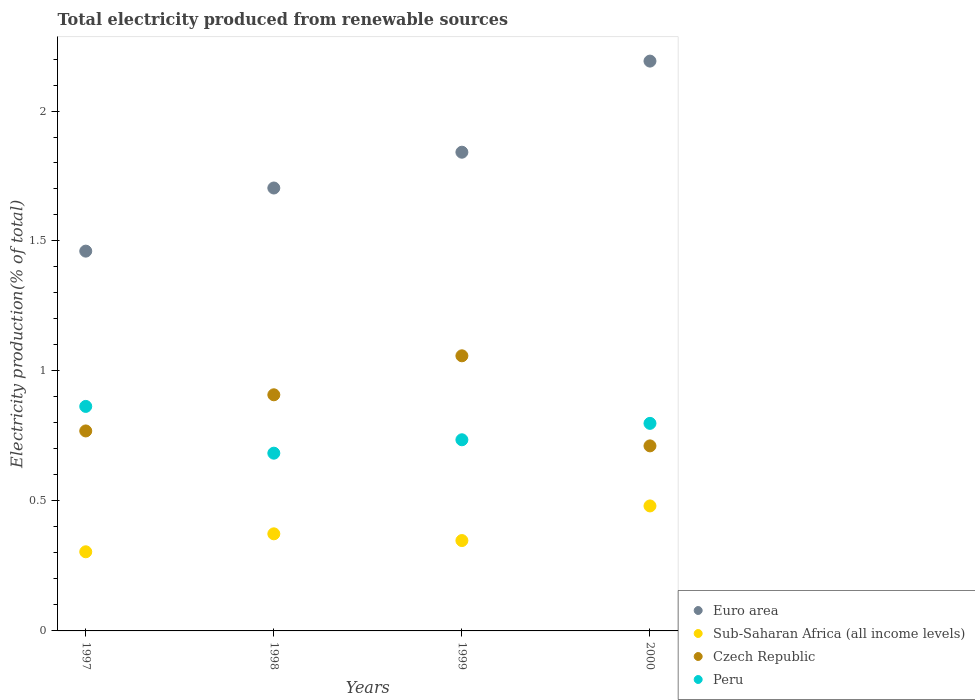How many different coloured dotlines are there?
Offer a very short reply. 4. Is the number of dotlines equal to the number of legend labels?
Provide a short and direct response. Yes. What is the total electricity produced in Euro area in 1999?
Your answer should be compact. 1.84. Across all years, what is the maximum total electricity produced in Czech Republic?
Make the answer very short. 1.06. Across all years, what is the minimum total electricity produced in Sub-Saharan Africa (all income levels)?
Keep it short and to the point. 0.3. What is the total total electricity produced in Sub-Saharan Africa (all income levels) in the graph?
Your response must be concise. 1.51. What is the difference between the total electricity produced in Euro area in 1997 and that in 1998?
Give a very brief answer. -0.24. What is the difference between the total electricity produced in Euro area in 1998 and the total electricity produced in Czech Republic in 1999?
Ensure brevity in your answer.  0.65. What is the average total electricity produced in Peru per year?
Ensure brevity in your answer.  0.77. In the year 1998, what is the difference between the total electricity produced in Peru and total electricity produced in Czech Republic?
Offer a very short reply. -0.22. In how many years, is the total electricity produced in Peru greater than 0.1 %?
Your answer should be very brief. 4. What is the ratio of the total electricity produced in Czech Republic in 1998 to that in 2000?
Give a very brief answer. 1.28. Is the total electricity produced in Peru in 1998 less than that in 2000?
Your answer should be compact. Yes. What is the difference between the highest and the second highest total electricity produced in Sub-Saharan Africa (all income levels)?
Keep it short and to the point. 0.11. What is the difference between the highest and the lowest total electricity produced in Peru?
Your answer should be very brief. 0.18. In how many years, is the total electricity produced in Czech Republic greater than the average total electricity produced in Czech Republic taken over all years?
Ensure brevity in your answer.  2. Is it the case that in every year, the sum of the total electricity produced in Czech Republic and total electricity produced in Sub-Saharan Africa (all income levels)  is greater than the sum of total electricity produced in Peru and total electricity produced in Euro area?
Your response must be concise. No. Does the total electricity produced in Euro area monotonically increase over the years?
Give a very brief answer. Yes. Is the total electricity produced in Sub-Saharan Africa (all income levels) strictly less than the total electricity produced in Czech Republic over the years?
Your answer should be compact. Yes. How many years are there in the graph?
Provide a short and direct response. 4. Does the graph contain any zero values?
Your response must be concise. No. Where does the legend appear in the graph?
Keep it short and to the point. Bottom right. What is the title of the graph?
Your answer should be compact. Total electricity produced from renewable sources. What is the label or title of the Y-axis?
Your response must be concise. Electricity production(% of total). What is the Electricity production(% of total) of Euro area in 1997?
Offer a terse response. 1.46. What is the Electricity production(% of total) of Sub-Saharan Africa (all income levels) in 1997?
Provide a short and direct response. 0.3. What is the Electricity production(% of total) of Czech Republic in 1997?
Make the answer very short. 0.77. What is the Electricity production(% of total) of Peru in 1997?
Keep it short and to the point. 0.86. What is the Electricity production(% of total) in Euro area in 1998?
Your answer should be very brief. 1.7. What is the Electricity production(% of total) in Sub-Saharan Africa (all income levels) in 1998?
Your answer should be compact. 0.37. What is the Electricity production(% of total) of Czech Republic in 1998?
Give a very brief answer. 0.91. What is the Electricity production(% of total) in Peru in 1998?
Keep it short and to the point. 0.68. What is the Electricity production(% of total) of Euro area in 1999?
Give a very brief answer. 1.84. What is the Electricity production(% of total) of Sub-Saharan Africa (all income levels) in 1999?
Keep it short and to the point. 0.35. What is the Electricity production(% of total) of Czech Republic in 1999?
Make the answer very short. 1.06. What is the Electricity production(% of total) of Peru in 1999?
Make the answer very short. 0.74. What is the Electricity production(% of total) of Euro area in 2000?
Offer a very short reply. 2.19. What is the Electricity production(% of total) of Sub-Saharan Africa (all income levels) in 2000?
Your response must be concise. 0.48. What is the Electricity production(% of total) in Czech Republic in 2000?
Ensure brevity in your answer.  0.71. What is the Electricity production(% of total) in Peru in 2000?
Your response must be concise. 0.8. Across all years, what is the maximum Electricity production(% of total) in Euro area?
Give a very brief answer. 2.19. Across all years, what is the maximum Electricity production(% of total) of Sub-Saharan Africa (all income levels)?
Keep it short and to the point. 0.48. Across all years, what is the maximum Electricity production(% of total) of Czech Republic?
Give a very brief answer. 1.06. Across all years, what is the maximum Electricity production(% of total) of Peru?
Give a very brief answer. 0.86. Across all years, what is the minimum Electricity production(% of total) in Euro area?
Ensure brevity in your answer.  1.46. Across all years, what is the minimum Electricity production(% of total) in Sub-Saharan Africa (all income levels)?
Provide a succinct answer. 0.3. Across all years, what is the minimum Electricity production(% of total) in Czech Republic?
Your response must be concise. 0.71. Across all years, what is the minimum Electricity production(% of total) of Peru?
Your answer should be very brief. 0.68. What is the total Electricity production(% of total) in Euro area in the graph?
Your answer should be very brief. 7.2. What is the total Electricity production(% of total) of Sub-Saharan Africa (all income levels) in the graph?
Your response must be concise. 1.51. What is the total Electricity production(% of total) in Czech Republic in the graph?
Your answer should be very brief. 3.45. What is the total Electricity production(% of total) in Peru in the graph?
Your answer should be very brief. 3.08. What is the difference between the Electricity production(% of total) in Euro area in 1997 and that in 1998?
Provide a succinct answer. -0.24. What is the difference between the Electricity production(% of total) in Sub-Saharan Africa (all income levels) in 1997 and that in 1998?
Provide a succinct answer. -0.07. What is the difference between the Electricity production(% of total) in Czech Republic in 1997 and that in 1998?
Your answer should be compact. -0.14. What is the difference between the Electricity production(% of total) in Peru in 1997 and that in 1998?
Offer a terse response. 0.18. What is the difference between the Electricity production(% of total) of Euro area in 1997 and that in 1999?
Your answer should be very brief. -0.38. What is the difference between the Electricity production(% of total) in Sub-Saharan Africa (all income levels) in 1997 and that in 1999?
Your answer should be compact. -0.04. What is the difference between the Electricity production(% of total) of Czech Republic in 1997 and that in 1999?
Make the answer very short. -0.29. What is the difference between the Electricity production(% of total) in Peru in 1997 and that in 1999?
Keep it short and to the point. 0.13. What is the difference between the Electricity production(% of total) of Euro area in 1997 and that in 2000?
Offer a terse response. -0.73. What is the difference between the Electricity production(% of total) of Sub-Saharan Africa (all income levels) in 1997 and that in 2000?
Offer a terse response. -0.18. What is the difference between the Electricity production(% of total) of Czech Republic in 1997 and that in 2000?
Offer a very short reply. 0.06. What is the difference between the Electricity production(% of total) in Peru in 1997 and that in 2000?
Offer a terse response. 0.07. What is the difference between the Electricity production(% of total) of Euro area in 1998 and that in 1999?
Keep it short and to the point. -0.14. What is the difference between the Electricity production(% of total) of Sub-Saharan Africa (all income levels) in 1998 and that in 1999?
Keep it short and to the point. 0.03. What is the difference between the Electricity production(% of total) of Czech Republic in 1998 and that in 1999?
Your answer should be compact. -0.15. What is the difference between the Electricity production(% of total) in Peru in 1998 and that in 1999?
Ensure brevity in your answer.  -0.05. What is the difference between the Electricity production(% of total) of Euro area in 1998 and that in 2000?
Your answer should be compact. -0.49. What is the difference between the Electricity production(% of total) of Sub-Saharan Africa (all income levels) in 1998 and that in 2000?
Your answer should be compact. -0.11. What is the difference between the Electricity production(% of total) in Czech Republic in 1998 and that in 2000?
Offer a very short reply. 0.2. What is the difference between the Electricity production(% of total) in Peru in 1998 and that in 2000?
Make the answer very short. -0.11. What is the difference between the Electricity production(% of total) in Euro area in 1999 and that in 2000?
Provide a succinct answer. -0.35. What is the difference between the Electricity production(% of total) of Sub-Saharan Africa (all income levels) in 1999 and that in 2000?
Offer a very short reply. -0.13. What is the difference between the Electricity production(% of total) in Czech Republic in 1999 and that in 2000?
Offer a terse response. 0.35. What is the difference between the Electricity production(% of total) in Peru in 1999 and that in 2000?
Offer a terse response. -0.06. What is the difference between the Electricity production(% of total) of Euro area in 1997 and the Electricity production(% of total) of Sub-Saharan Africa (all income levels) in 1998?
Provide a short and direct response. 1.09. What is the difference between the Electricity production(% of total) in Euro area in 1997 and the Electricity production(% of total) in Czech Republic in 1998?
Keep it short and to the point. 0.55. What is the difference between the Electricity production(% of total) in Euro area in 1997 and the Electricity production(% of total) in Peru in 1998?
Offer a very short reply. 0.78. What is the difference between the Electricity production(% of total) in Sub-Saharan Africa (all income levels) in 1997 and the Electricity production(% of total) in Czech Republic in 1998?
Make the answer very short. -0.6. What is the difference between the Electricity production(% of total) in Sub-Saharan Africa (all income levels) in 1997 and the Electricity production(% of total) in Peru in 1998?
Provide a short and direct response. -0.38. What is the difference between the Electricity production(% of total) of Czech Republic in 1997 and the Electricity production(% of total) of Peru in 1998?
Your answer should be very brief. 0.09. What is the difference between the Electricity production(% of total) in Euro area in 1997 and the Electricity production(% of total) in Sub-Saharan Africa (all income levels) in 1999?
Offer a very short reply. 1.11. What is the difference between the Electricity production(% of total) in Euro area in 1997 and the Electricity production(% of total) in Czech Republic in 1999?
Provide a succinct answer. 0.4. What is the difference between the Electricity production(% of total) in Euro area in 1997 and the Electricity production(% of total) in Peru in 1999?
Give a very brief answer. 0.73. What is the difference between the Electricity production(% of total) of Sub-Saharan Africa (all income levels) in 1997 and the Electricity production(% of total) of Czech Republic in 1999?
Your answer should be very brief. -0.75. What is the difference between the Electricity production(% of total) in Sub-Saharan Africa (all income levels) in 1997 and the Electricity production(% of total) in Peru in 1999?
Give a very brief answer. -0.43. What is the difference between the Electricity production(% of total) in Czech Republic in 1997 and the Electricity production(% of total) in Peru in 1999?
Offer a very short reply. 0.03. What is the difference between the Electricity production(% of total) of Euro area in 1997 and the Electricity production(% of total) of Sub-Saharan Africa (all income levels) in 2000?
Your answer should be very brief. 0.98. What is the difference between the Electricity production(% of total) in Euro area in 1997 and the Electricity production(% of total) in Czech Republic in 2000?
Give a very brief answer. 0.75. What is the difference between the Electricity production(% of total) of Euro area in 1997 and the Electricity production(% of total) of Peru in 2000?
Provide a short and direct response. 0.66. What is the difference between the Electricity production(% of total) of Sub-Saharan Africa (all income levels) in 1997 and the Electricity production(% of total) of Czech Republic in 2000?
Ensure brevity in your answer.  -0.41. What is the difference between the Electricity production(% of total) of Sub-Saharan Africa (all income levels) in 1997 and the Electricity production(% of total) of Peru in 2000?
Ensure brevity in your answer.  -0.49. What is the difference between the Electricity production(% of total) in Czech Republic in 1997 and the Electricity production(% of total) in Peru in 2000?
Your answer should be compact. -0.03. What is the difference between the Electricity production(% of total) in Euro area in 1998 and the Electricity production(% of total) in Sub-Saharan Africa (all income levels) in 1999?
Give a very brief answer. 1.36. What is the difference between the Electricity production(% of total) in Euro area in 1998 and the Electricity production(% of total) in Czech Republic in 1999?
Your response must be concise. 0.65. What is the difference between the Electricity production(% of total) in Euro area in 1998 and the Electricity production(% of total) in Peru in 1999?
Your answer should be very brief. 0.97. What is the difference between the Electricity production(% of total) of Sub-Saharan Africa (all income levels) in 1998 and the Electricity production(% of total) of Czech Republic in 1999?
Your answer should be compact. -0.68. What is the difference between the Electricity production(% of total) in Sub-Saharan Africa (all income levels) in 1998 and the Electricity production(% of total) in Peru in 1999?
Your response must be concise. -0.36. What is the difference between the Electricity production(% of total) in Czech Republic in 1998 and the Electricity production(% of total) in Peru in 1999?
Provide a succinct answer. 0.17. What is the difference between the Electricity production(% of total) of Euro area in 1998 and the Electricity production(% of total) of Sub-Saharan Africa (all income levels) in 2000?
Provide a succinct answer. 1.22. What is the difference between the Electricity production(% of total) of Euro area in 1998 and the Electricity production(% of total) of Peru in 2000?
Give a very brief answer. 0.91. What is the difference between the Electricity production(% of total) in Sub-Saharan Africa (all income levels) in 1998 and the Electricity production(% of total) in Czech Republic in 2000?
Make the answer very short. -0.34. What is the difference between the Electricity production(% of total) in Sub-Saharan Africa (all income levels) in 1998 and the Electricity production(% of total) in Peru in 2000?
Provide a short and direct response. -0.42. What is the difference between the Electricity production(% of total) of Czech Republic in 1998 and the Electricity production(% of total) of Peru in 2000?
Make the answer very short. 0.11. What is the difference between the Electricity production(% of total) in Euro area in 1999 and the Electricity production(% of total) in Sub-Saharan Africa (all income levels) in 2000?
Make the answer very short. 1.36. What is the difference between the Electricity production(% of total) in Euro area in 1999 and the Electricity production(% of total) in Czech Republic in 2000?
Make the answer very short. 1.13. What is the difference between the Electricity production(% of total) of Euro area in 1999 and the Electricity production(% of total) of Peru in 2000?
Ensure brevity in your answer.  1.04. What is the difference between the Electricity production(% of total) in Sub-Saharan Africa (all income levels) in 1999 and the Electricity production(% of total) in Czech Republic in 2000?
Your answer should be compact. -0.36. What is the difference between the Electricity production(% of total) of Sub-Saharan Africa (all income levels) in 1999 and the Electricity production(% of total) of Peru in 2000?
Provide a succinct answer. -0.45. What is the difference between the Electricity production(% of total) in Czech Republic in 1999 and the Electricity production(% of total) in Peru in 2000?
Provide a succinct answer. 0.26. What is the average Electricity production(% of total) of Euro area per year?
Your answer should be compact. 1.8. What is the average Electricity production(% of total) in Sub-Saharan Africa (all income levels) per year?
Ensure brevity in your answer.  0.38. What is the average Electricity production(% of total) in Czech Republic per year?
Provide a short and direct response. 0.86. What is the average Electricity production(% of total) of Peru per year?
Keep it short and to the point. 0.77. In the year 1997, what is the difference between the Electricity production(% of total) of Euro area and Electricity production(% of total) of Sub-Saharan Africa (all income levels)?
Your answer should be compact. 1.16. In the year 1997, what is the difference between the Electricity production(% of total) of Euro area and Electricity production(% of total) of Czech Republic?
Offer a very short reply. 0.69. In the year 1997, what is the difference between the Electricity production(% of total) of Euro area and Electricity production(% of total) of Peru?
Your response must be concise. 0.6. In the year 1997, what is the difference between the Electricity production(% of total) of Sub-Saharan Africa (all income levels) and Electricity production(% of total) of Czech Republic?
Provide a short and direct response. -0.46. In the year 1997, what is the difference between the Electricity production(% of total) in Sub-Saharan Africa (all income levels) and Electricity production(% of total) in Peru?
Provide a succinct answer. -0.56. In the year 1997, what is the difference between the Electricity production(% of total) of Czech Republic and Electricity production(% of total) of Peru?
Your answer should be very brief. -0.09. In the year 1998, what is the difference between the Electricity production(% of total) of Euro area and Electricity production(% of total) of Sub-Saharan Africa (all income levels)?
Your answer should be compact. 1.33. In the year 1998, what is the difference between the Electricity production(% of total) of Euro area and Electricity production(% of total) of Czech Republic?
Provide a succinct answer. 0.8. In the year 1998, what is the difference between the Electricity production(% of total) of Euro area and Electricity production(% of total) of Peru?
Your answer should be compact. 1.02. In the year 1998, what is the difference between the Electricity production(% of total) in Sub-Saharan Africa (all income levels) and Electricity production(% of total) in Czech Republic?
Ensure brevity in your answer.  -0.53. In the year 1998, what is the difference between the Electricity production(% of total) of Sub-Saharan Africa (all income levels) and Electricity production(% of total) of Peru?
Give a very brief answer. -0.31. In the year 1998, what is the difference between the Electricity production(% of total) of Czech Republic and Electricity production(% of total) of Peru?
Ensure brevity in your answer.  0.22. In the year 1999, what is the difference between the Electricity production(% of total) in Euro area and Electricity production(% of total) in Sub-Saharan Africa (all income levels)?
Give a very brief answer. 1.49. In the year 1999, what is the difference between the Electricity production(% of total) of Euro area and Electricity production(% of total) of Czech Republic?
Keep it short and to the point. 0.78. In the year 1999, what is the difference between the Electricity production(% of total) in Euro area and Electricity production(% of total) in Peru?
Keep it short and to the point. 1.11. In the year 1999, what is the difference between the Electricity production(% of total) of Sub-Saharan Africa (all income levels) and Electricity production(% of total) of Czech Republic?
Provide a short and direct response. -0.71. In the year 1999, what is the difference between the Electricity production(% of total) of Sub-Saharan Africa (all income levels) and Electricity production(% of total) of Peru?
Provide a short and direct response. -0.39. In the year 1999, what is the difference between the Electricity production(% of total) in Czech Republic and Electricity production(% of total) in Peru?
Provide a short and direct response. 0.32. In the year 2000, what is the difference between the Electricity production(% of total) in Euro area and Electricity production(% of total) in Sub-Saharan Africa (all income levels)?
Offer a very short reply. 1.71. In the year 2000, what is the difference between the Electricity production(% of total) in Euro area and Electricity production(% of total) in Czech Republic?
Your response must be concise. 1.48. In the year 2000, what is the difference between the Electricity production(% of total) of Euro area and Electricity production(% of total) of Peru?
Your answer should be compact. 1.39. In the year 2000, what is the difference between the Electricity production(% of total) in Sub-Saharan Africa (all income levels) and Electricity production(% of total) in Czech Republic?
Provide a succinct answer. -0.23. In the year 2000, what is the difference between the Electricity production(% of total) of Sub-Saharan Africa (all income levels) and Electricity production(% of total) of Peru?
Offer a terse response. -0.32. In the year 2000, what is the difference between the Electricity production(% of total) in Czech Republic and Electricity production(% of total) in Peru?
Ensure brevity in your answer.  -0.09. What is the ratio of the Electricity production(% of total) of Euro area in 1997 to that in 1998?
Give a very brief answer. 0.86. What is the ratio of the Electricity production(% of total) in Sub-Saharan Africa (all income levels) in 1997 to that in 1998?
Make the answer very short. 0.81. What is the ratio of the Electricity production(% of total) in Czech Republic in 1997 to that in 1998?
Keep it short and to the point. 0.85. What is the ratio of the Electricity production(% of total) in Peru in 1997 to that in 1998?
Offer a terse response. 1.26. What is the ratio of the Electricity production(% of total) in Euro area in 1997 to that in 1999?
Your response must be concise. 0.79. What is the ratio of the Electricity production(% of total) in Sub-Saharan Africa (all income levels) in 1997 to that in 1999?
Your answer should be compact. 0.88. What is the ratio of the Electricity production(% of total) of Czech Republic in 1997 to that in 1999?
Your answer should be very brief. 0.73. What is the ratio of the Electricity production(% of total) of Peru in 1997 to that in 1999?
Give a very brief answer. 1.17. What is the ratio of the Electricity production(% of total) in Euro area in 1997 to that in 2000?
Offer a very short reply. 0.67. What is the ratio of the Electricity production(% of total) in Sub-Saharan Africa (all income levels) in 1997 to that in 2000?
Give a very brief answer. 0.63. What is the ratio of the Electricity production(% of total) in Czech Republic in 1997 to that in 2000?
Your answer should be very brief. 1.08. What is the ratio of the Electricity production(% of total) in Peru in 1997 to that in 2000?
Your answer should be very brief. 1.08. What is the ratio of the Electricity production(% of total) of Euro area in 1998 to that in 1999?
Your answer should be very brief. 0.93. What is the ratio of the Electricity production(% of total) of Sub-Saharan Africa (all income levels) in 1998 to that in 1999?
Offer a terse response. 1.07. What is the ratio of the Electricity production(% of total) in Czech Republic in 1998 to that in 1999?
Offer a terse response. 0.86. What is the ratio of the Electricity production(% of total) in Peru in 1998 to that in 1999?
Your response must be concise. 0.93. What is the ratio of the Electricity production(% of total) of Euro area in 1998 to that in 2000?
Give a very brief answer. 0.78. What is the ratio of the Electricity production(% of total) of Sub-Saharan Africa (all income levels) in 1998 to that in 2000?
Make the answer very short. 0.78. What is the ratio of the Electricity production(% of total) of Czech Republic in 1998 to that in 2000?
Provide a succinct answer. 1.28. What is the ratio of the Electricity production(% of total) in Peru in 1998 to that in 2000?
Your answer should be very brief. 0.86. What is the ratio of the Electricity production(% of total) of Euro area in 1999 to that in 2000?
Your answer should be compact. 0.84. What is the ratio of the Electricity production(% of total) of Sub-Saharan Africa (all income levels) in 1999 to that in 2000?
Offer a very short reply. 0.72. What is the ratio of the Electricity production(% of total) of Czech Republic in 1999 to that in 2000?
Provide a short and direct response. 1.49. What is the ratio of the Electricity production(% of total) in Peru in 1999 to that in 2000?
Your answer should be compact. 0.92. What is the difference between the highest and the second highest Electricity production(% of total) of Euro area?
Keep it short and to the point. 0.35. What is the difference between the highest and the second highest Electricity production(% of total) in Sub-Saharan Africa (all income levels)?
Offer a very short reply. 0.11. What is the difference between the highest and the second highest Electricity production(% of total) of Czech Republic?
Ensure brevity in your answer.  0.15. What is the difference between the highest and the second highest Electricity production(% of total) in Peru?
Make the answer very short. 0.07. What is the difference between the highest and the lowest Electricity production(% of total) in Euro area?
Make the answer very short. 0.73. What is the difference between the highest and the lowest Electricity production(% of total) in Sub-Saharan Africa (all income levels)?
Your answer should be compact. 0.18. What is the difference between the highest and the lowest Electricity production(% of total) in Czech Republic?
Your response must be concise. 0.35. What is the difference between the highest and the lowest Electricity production(% of total) of Peru?
Provide a succinct answer. 0.18. 